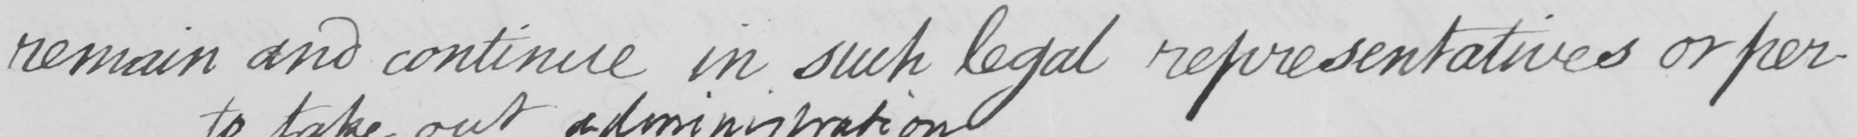Can you read and transcribe this handwriting? remain and continue in such legal representatives or per- 